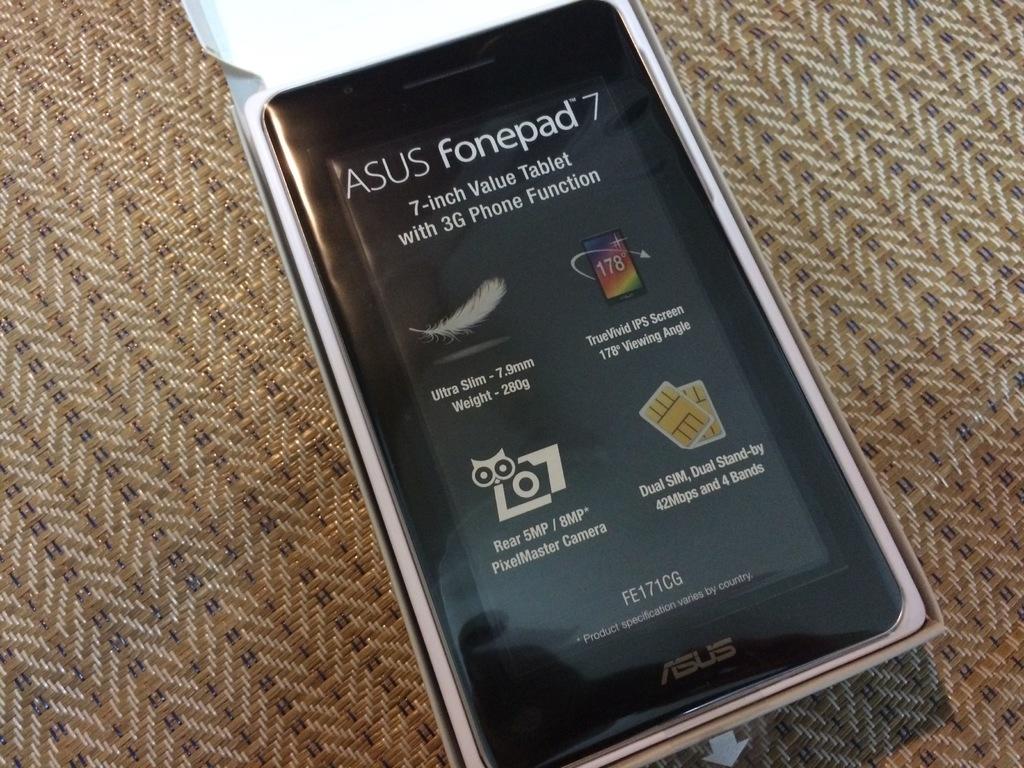Who makes this phone?
Offer a terse response. Asus. How many inches is the tablet?
Provide a succinct answer. 7. 